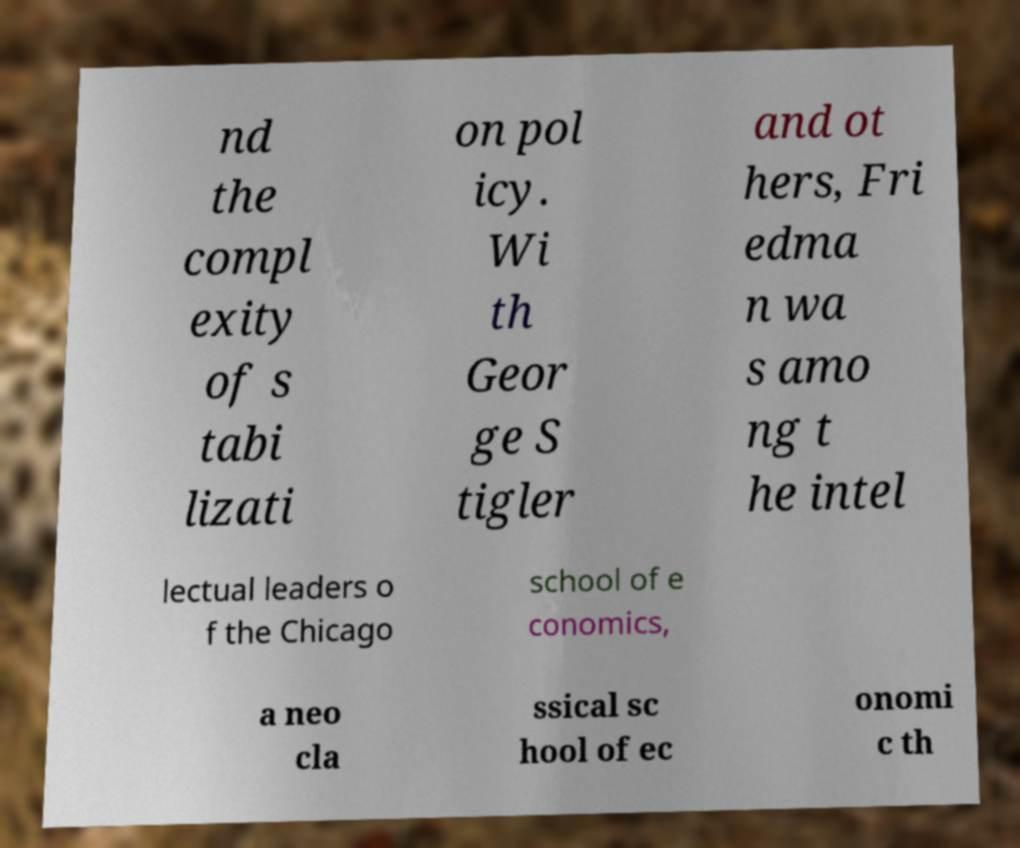Could you extract and type out the text from this image? nd the compl exity of s tabi lizati on pol icy. Wi th Geor ge S tigler and ot hers, Fri edma n wa s amo ng t he intel lectual leaders o f the Chicago school of e conomics, a neo cla ssical sc hool of ec onomi c th 